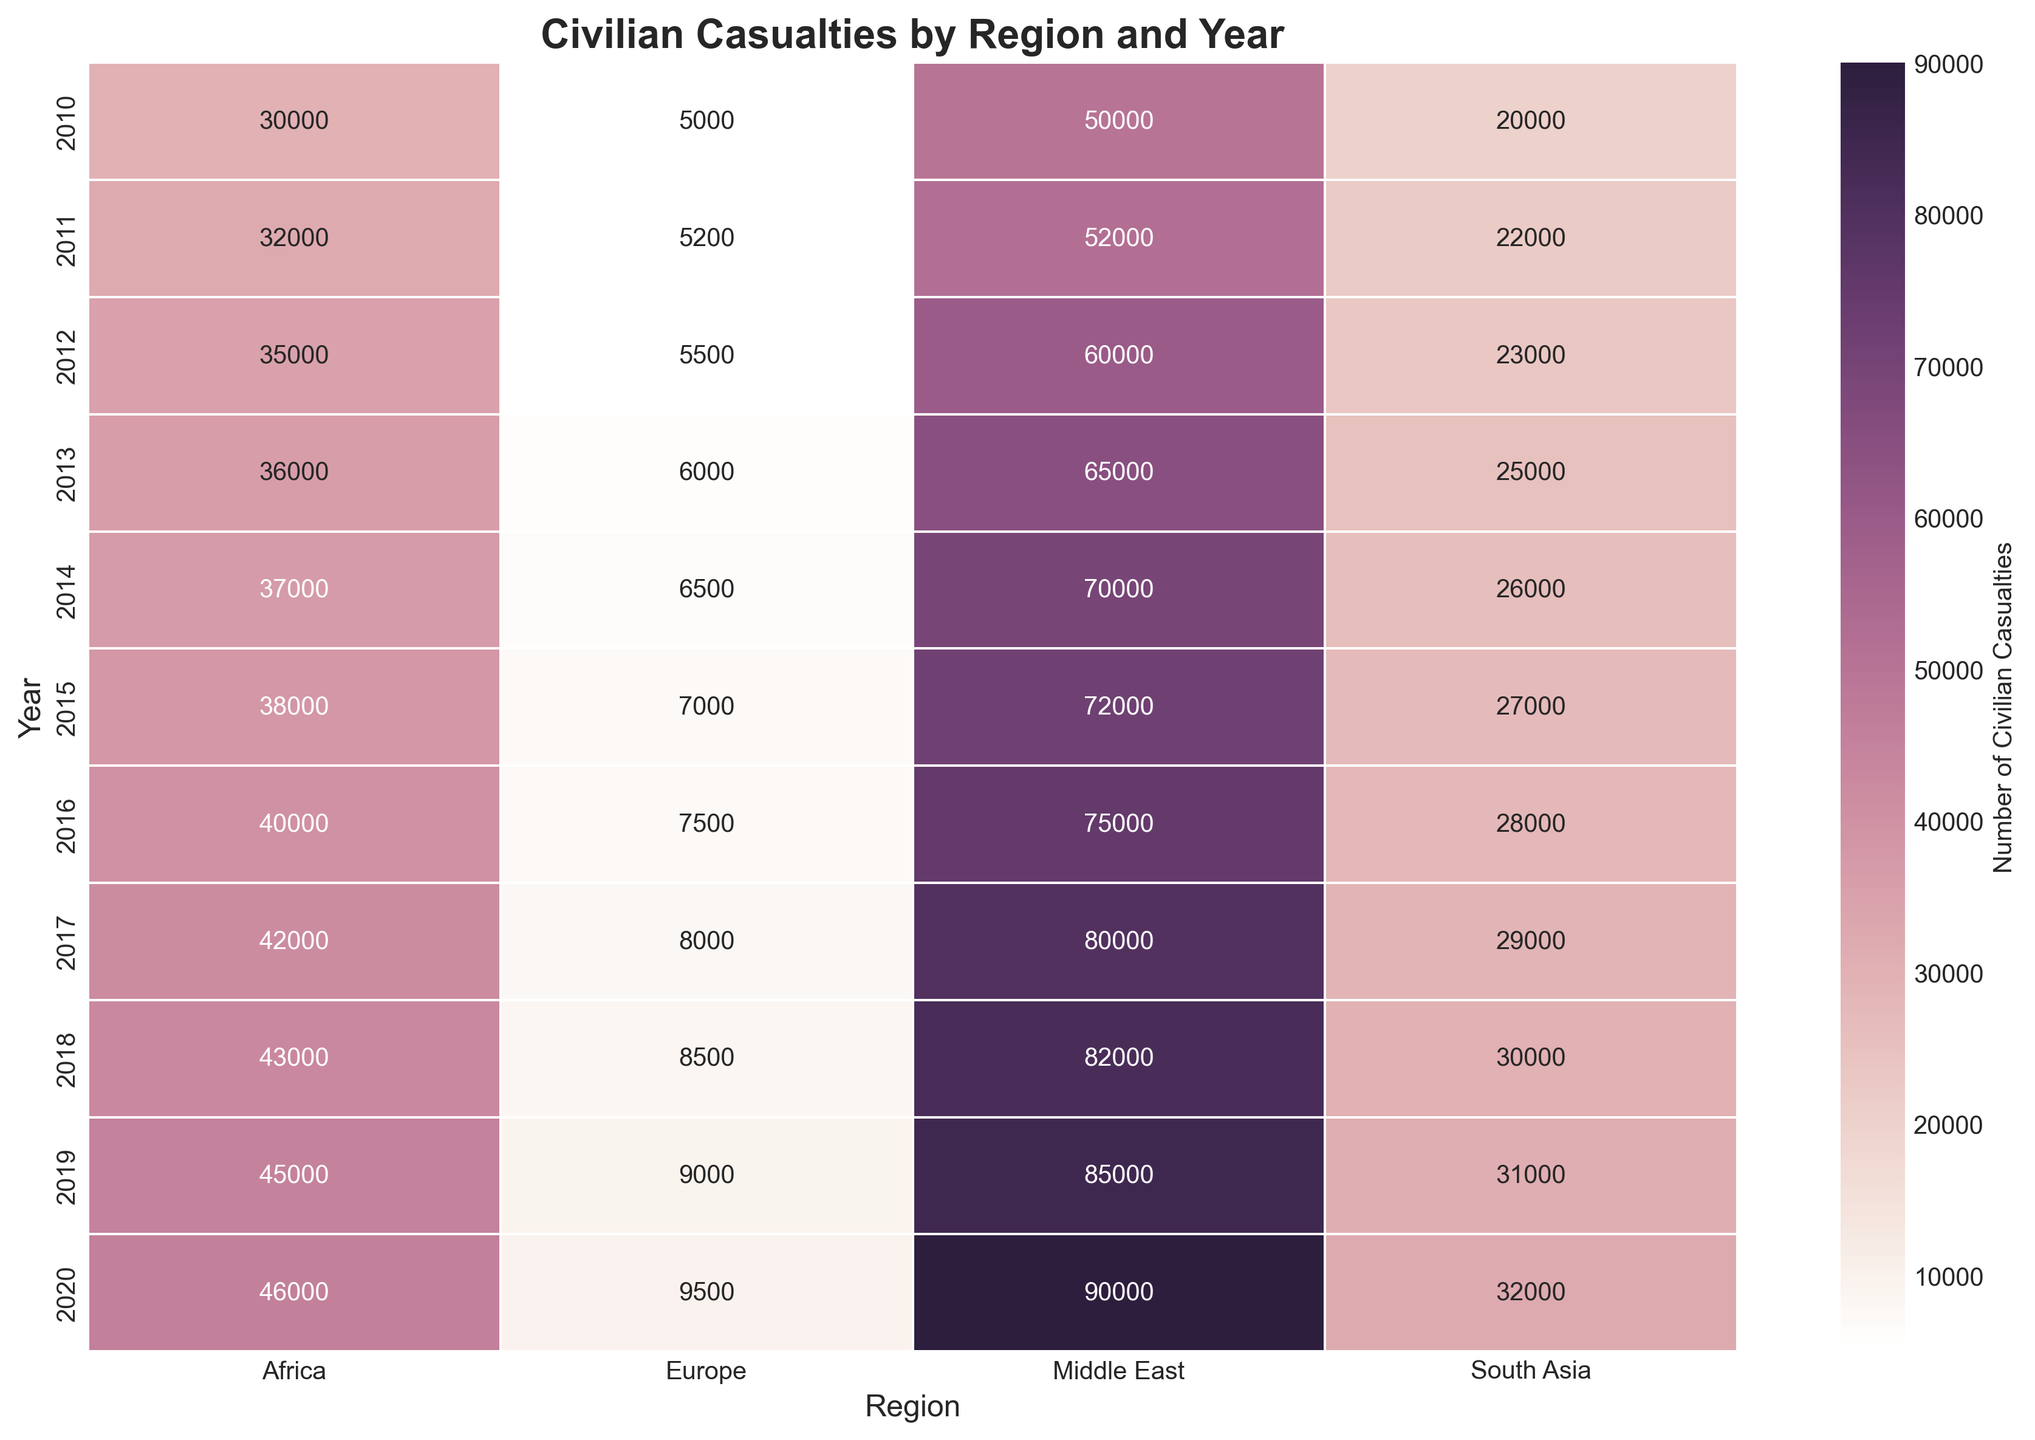what region had the highest number of civilian casualties in 2020? In 2020, looking at the heatmap, the Middle East column's value is the highest compared to other regions.
Answer: Middle East compare the number of civilian casualties in the Middle East and Africa in 2015. which region had more casualties? For 2015, the Middle East has a value of 72,000 and Africa has a value of 38,000. The value for the Middle East is higher.
Answer: Middle East what is the average number of civilian casualties in South Asia from 2010 to 2020? Sum the values for South Asia from 2010 (20,000) to 2020 (32,000) and divide by 11 years. Sum = 226,000 and average = 226,000 / 11 = 20,545.
Answer: 20,545 which year in Europe had the lowest number of civilian casualties, and what was the value? The lowest value in the Europe column is in 2010, with a value of 5,000.
Answer: 2010, 5,000 how does the trend of civilian casualties from 2010 to 2020 in Africa compare to that in the Middle East? The trend in Africa shows a gradual rise from 30,000 to 46,000. In the Middle East, there’s a sharper increase from 50,000 to 90,000. The increase in the Middle East is steeper and larger.
Answer: Middle East has a steeper increase which region had the most stable number of civilian casualties from 2010 to 2020? By examining the columns, Europe's values rise the least sharply, indicating more stability in casualty figures, ranging from 5,000 to 9,500.
Answer: Europe what is the difference in civilian casualties between 2017 and 2018 for South Asia? In 2017, South Asia’s value is 29,000, and in 2018, it is 30,000. The difference is 30,000 - 29,000 = 1,000.
Answer: 1,000 what year had the highest increase in civilian casualties in the Middle East compared to the previous year? Between 2010 to 2020, the highest increase was from 2013 (65,000) to 2014 (70,000), a difference of 5,000.
Answer: 2014 